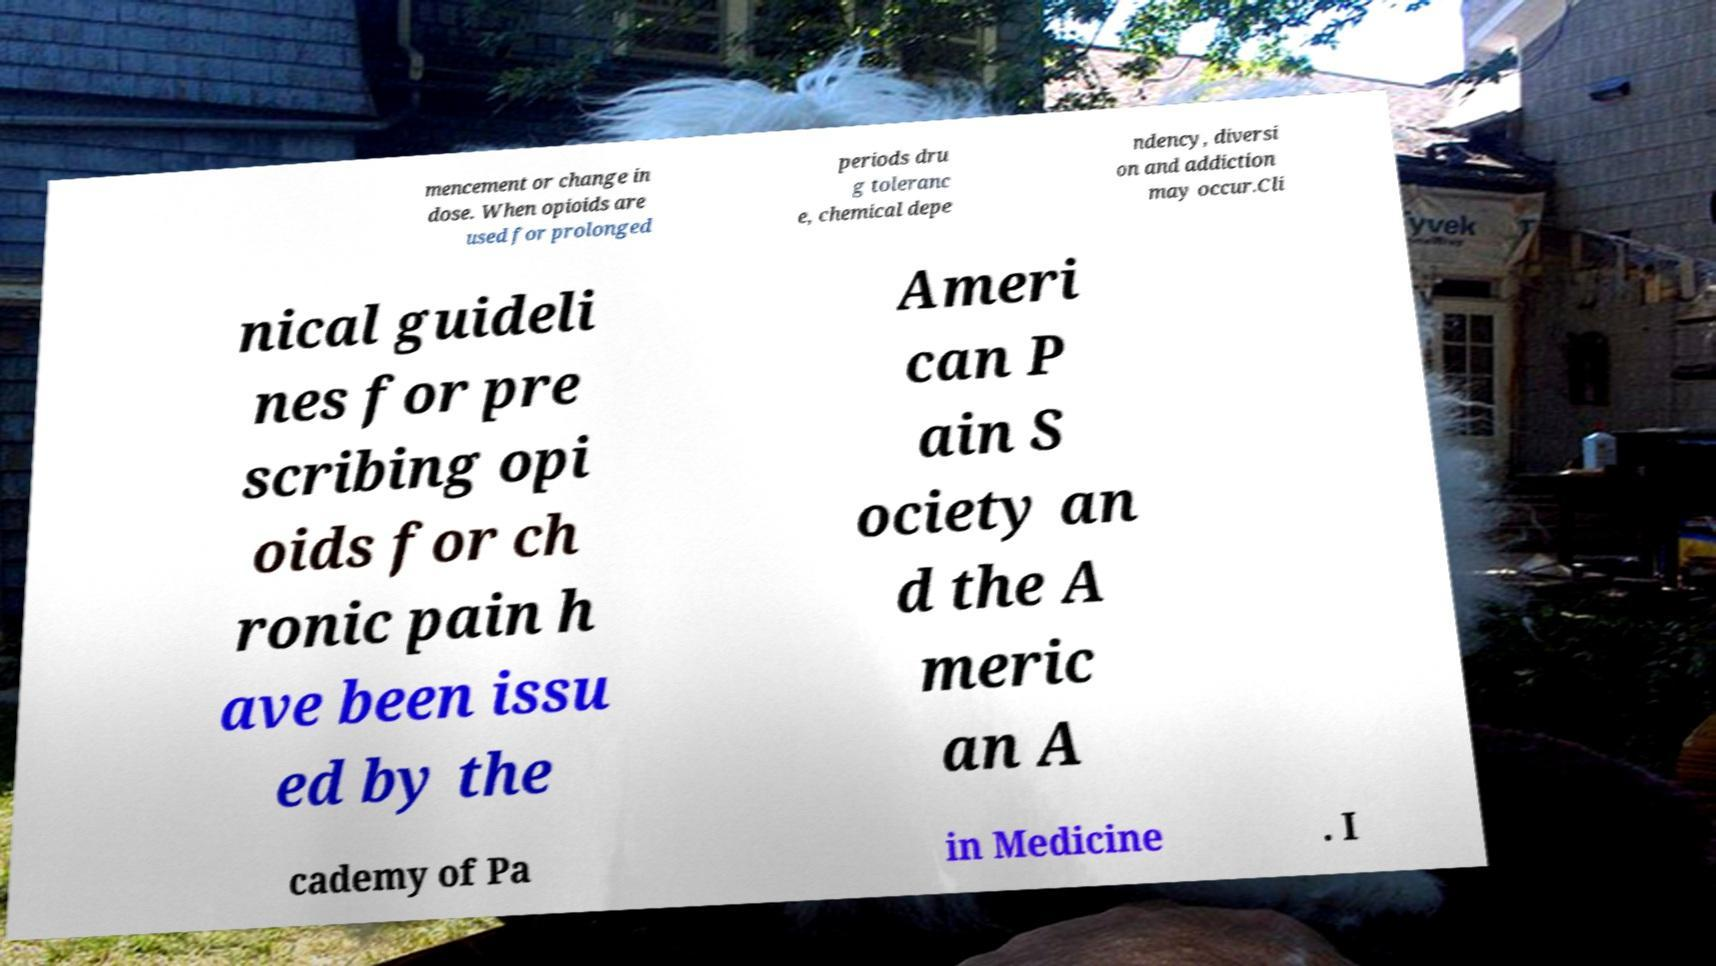Please identify and transcribe the text found in this image. mencement or change in dose. When opioids are used for prolonged periods dru g toleranc e, chemical depe ndency, diversi on and addiction may occur.Cli nical guideli nes for pre scribing opi oids for ch ronic pain h ave been issu ed by the Ameri can P ain S ociety an d the A meric an A cademy of Pa in Medicine . I 